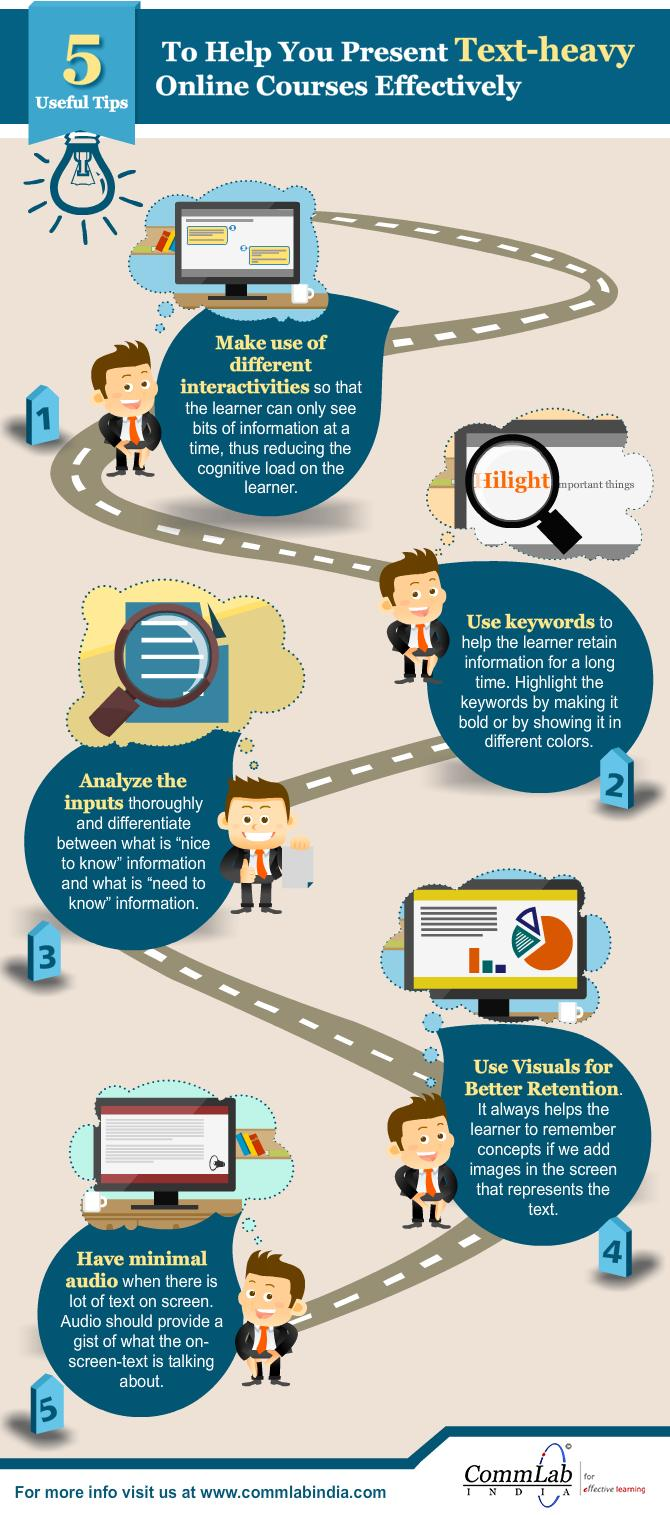Highlight a few significant elements in this photo. This infographic contains two search icons. 